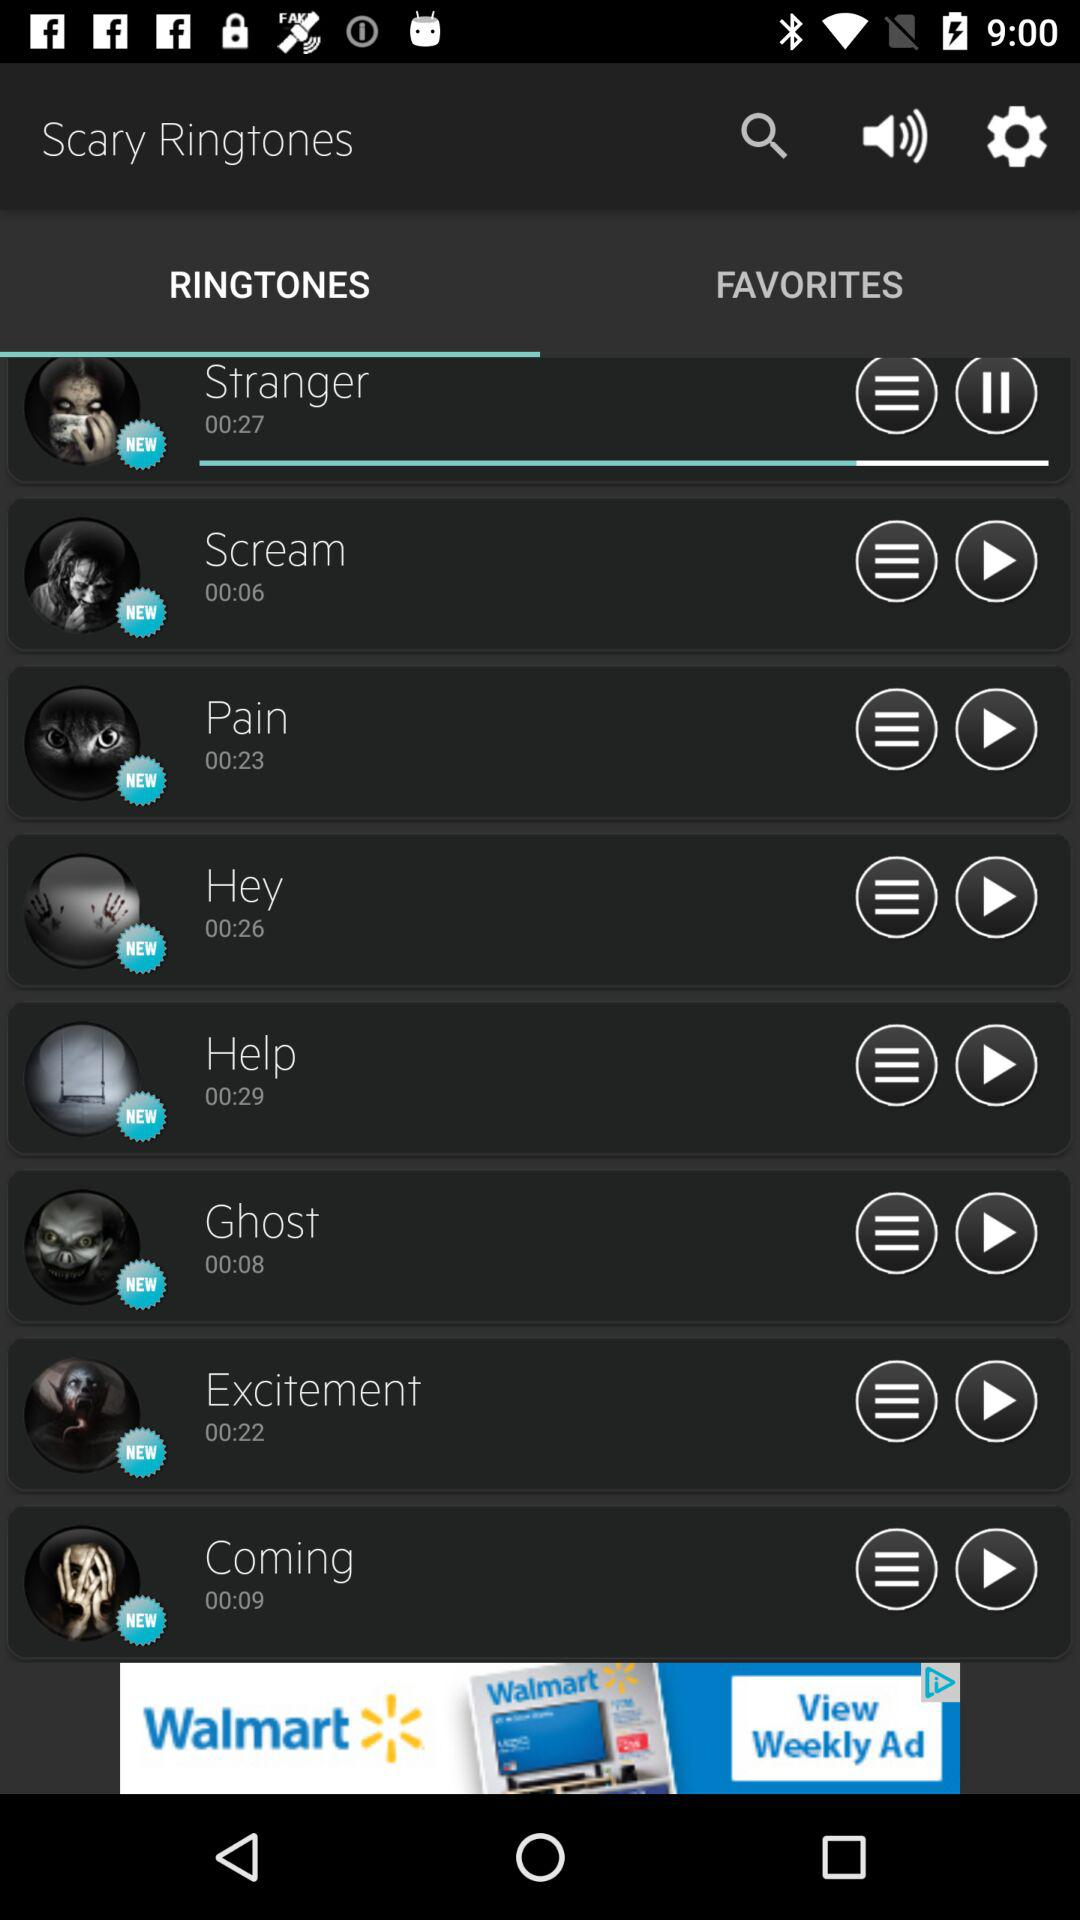What ringtone is playing? The ringtone playing is "Stranger". 